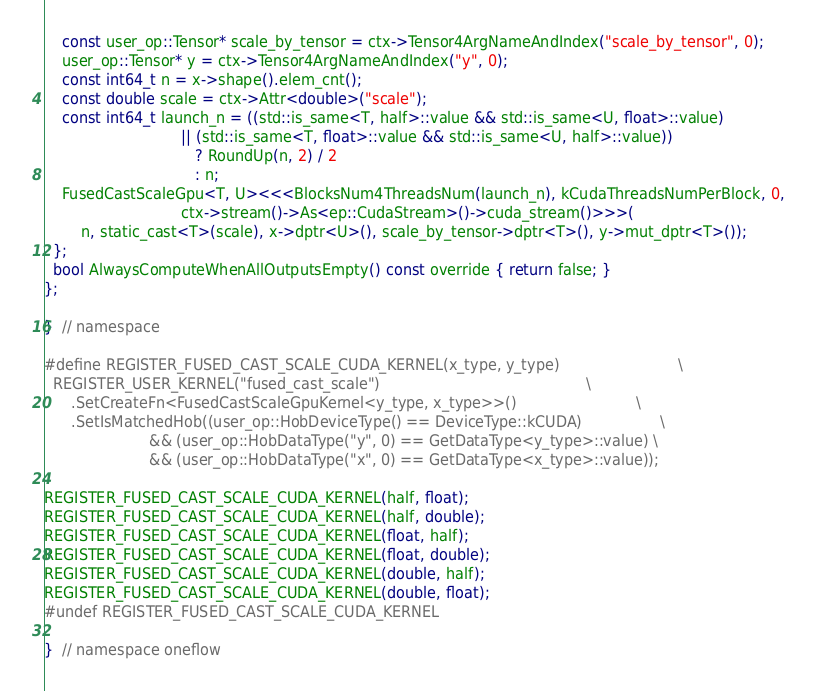<code> <loc_0><loc_0><loc_500><loc_500><_Cuda_>    const user_op::Tensor* scale_by_tensor = ctx->Tensor4ArgNameAndIndex("scale_by_tensor", 0);
    user_op::Tensor* y = ctx->Tensor4ArgNameAndIndex("y", 0);
    const int64_t n = x->shape().elem_cnt();
    const double scale = ctx->Attr<double>("scale");
    const int64_t launch_n = ((std::is_same<T, half>::value && std::is_same<U, float>::value)
                              || (std::is_same<T, float>::value && std::is_same<U, half>::value))
                                 ? RoundUp(n, 2) / 2
                                 : n;
    FusedCastScaleGpu<T, U><<<BlocksNum4ThreadsNum(launch_n), kCudaThreadsNumPerBlock, 0,
                              ctx->stream()->As<ep::CudaStream>()->cuda_stream()>>>(
        n, static_cast<T>(scale), x->dptr<U>(), scale_by_tensor->dptr<T>(), y->mut_dptr<T>());
  };
  bool AlwaysComputeWhenAllOutputsEmpty() const override { return false; }
};

}  // namespace

#define REGISTER_FUSED_CAST_SCALE_CUDA_KERNEL(x_type, y_type)                          \
  REGISTER_USER_KERNEL("fused_cast_scale")                                             \
      .SetCreateFn<FusedCastScaleGpuKernel<y_type, x_type>>()                          \
      .SetIsMatchedHob((user_op::HobDeviceType() == DeviceType::kCUDA)                 \
                       && (user_op::HobDataType("y", 0) == GetDataType<y_type>::value) \
                       && (user_op::HobDataType("x", 0) == GetDataType<x_type>::value));

REGISTER_FUSED_CAST_SCALE_CUDA_KERNEL(half, float);
REGISTER_FUSED_CAST_SCALE_CUDA_KERNEL(half, double);
REGISTER_FUSED_CAST_SCALE_CUDA_KERNEL(float, half);
REGISTER_FUSED_CAST_SCALE_CUDA_KERNEL(float, double);
REGISTER_FUSED_CAST_SCALE_CUDA_KERNEL(double, half);
REGISTER_FUSED_CAST_SCALE_CUDA_KERNEL(double, float);
#undef REGISTER_FUSED_CAST_SCALE_CUDA_KERNEL

}  // namespace oneflow
</code> 